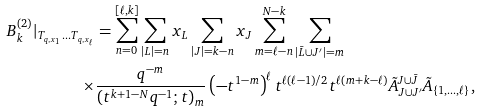<formula> <loc_0><loc_0><loc_500><loc_500>B _ { k } ^ { ( 2 ) } | _ { T _ { q , x _ { 1 } } \dots T _ { q , x _ { \ell } } } & = \sum _ { n = 0 } ^ { [ \ell , k ] } \sum _ { | L | = n } x _ { L } \sum _ { | J | = k - n } x _ { J } \sum _ { m = \ell - n } ^ { N - k } \sum _ { | \bar { L } \cup J ^ { \prime } | = m } \\ \times & \frac { q ^ { - m } } { ( t ^ { k + 1 - N } q ^ { - 1 } ; t ) _ { m } } \left ( - t ^ { 1 - m } \right ) ^ { \ell } t ^ { \ell ( \ell - 1 ) / 2 } t ^ { \ell ( m + k - \ell ) } \tilde { A } _ { J \cup J ^ { \prime } } ^ { J \cup \bar { J } } \tilde { A } _ { \{ 1 , \dots , \ell \} } ,</formula> 